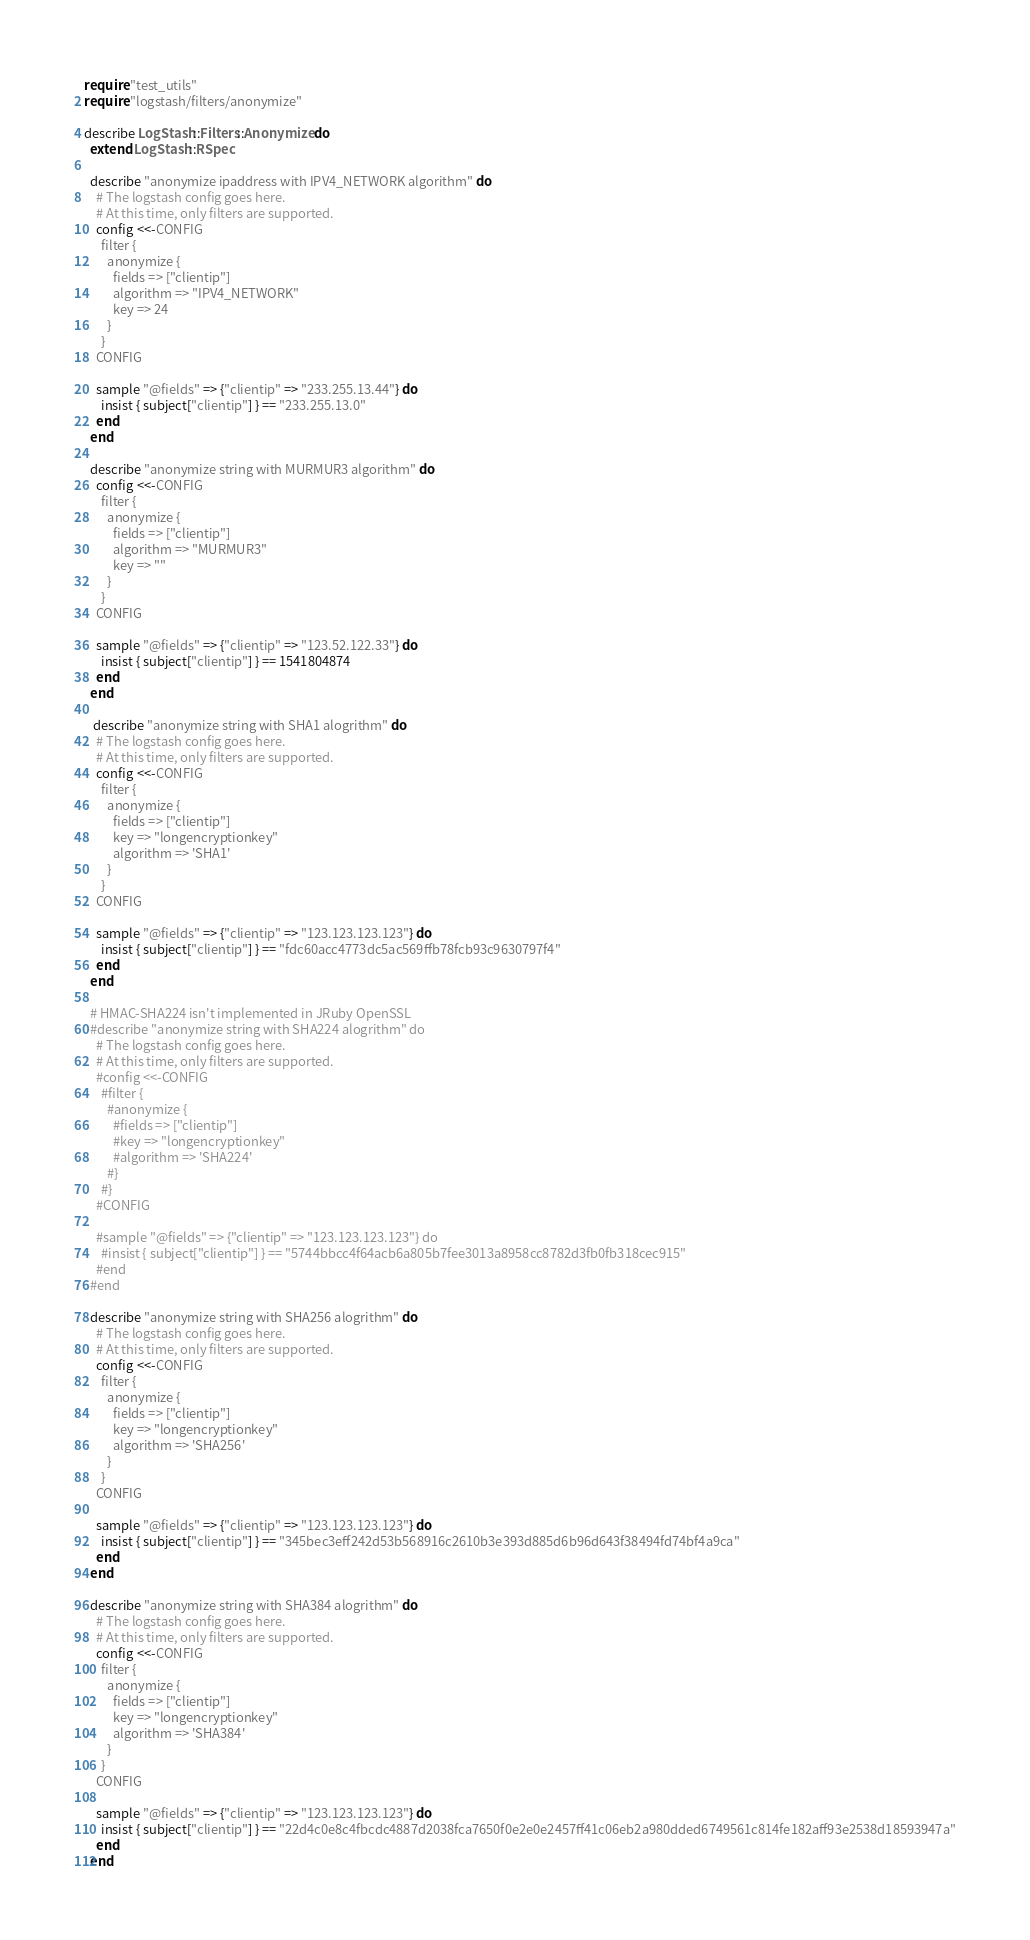<code> <loc_0><loc_0><loc_500><loc_500><_Ruby_>require "test_utils"
require "logstash/filters/anonymize"

describe LogStash::Filters::Anonymize do
  extend LogStash::RSpec

  describe "anonymize ipaddress with IPV4_NETWORK algorithm" do
    # The logstash config goes here.
    # At this time, only filters are supported.
    config <<-CONFIG
      filter {
        anonymize {
          fields => ["clientip"]
          algorithm => "IPV4_NETWORK"
          key => 24
        }
      }
    CONFIG

    sample "@fields" => {"clientip" => "233.255.13.44"} do
      insist { subject["clientip"] } == "233.255.13.0"
    end
  end

  describe "anonymize string with MURMUR3 algorithm" do
    config <<-CONFIG
      filter { 
        anonymize { 
          fields => ["clientip"]
          algorithm => "MURMUR3"
          key => ""
        }
      }
    CONFIG

    sample "@fields" => {"clientip" => "123.52.122.33"} do
      insist { subject["clientip"] } == 1541804874
    end
  end
 
   describe "anonymize string with SHA1 alogrithm" do
    # The logstash config goes here.
    # At this time, only filters are supported.
    config <<-CONFIG
      filter {
        anonymize {
          fields => ["clientip"]
          key => "longencryptionkey"
          algorithm => 'SHA1'
        }
      }
    CONFIG

    sample "@fields" => {"clientip" => "123.123.123.123"} do
      insist { subject["clientip"] } == "fdc60acc4773dc5ac569ffb78fcb93c9630797f4"
    end
  end

  # HMAC-SHA224 isn't implemented in JRuby OpenSSL
  #describe "anonymize string with SHA224 alogrithm" do
    # The logstash config goes here.
    # At this time, only filters are supported.
    #config <<-CONFIG
      #filter {
        #anonymize {
          #fields => ["clientip"]
          #key => "longencryptionkey"
          #algorithm => 'SHA224'
        #}
      #}
    #CONFIG

    #sample "@fields" => {"clientip" => "123.123.123.123"} do
      #insist { subject["clientip"] } == "5744bbcc4f64acb6a805b7fee3013a8958cc8782d3fb0fb318cec915"
    #end
  #end

  describe "anonymize string with SHA256 alogrithm" do
    # The logstash config goes here.
    # At this time, only filters are supported.
    config <<-CONFIG
      filter {
        anonymize {
          fields => ["clientip"]
          key => "longencryptionkey"
          algorithm => 'SHA256'
        }
      }
    CONFIG

    sample "@fields" => {"clientip" => "123.123.123.123"} do
      insist { subject["clientip"] } == "345bec3eff242d53b568916c2610b3e393d885d6b96d643f38494fd74bf4a9ca"
    end
  end

  describe "anonymize string with SHA384 alogrithm" do
    # The logstash config goes here.
    # At this time, only filters are supported.
    config <<-CONFIG
      filter {
        anonymize {
          fields => ["clientip"]
          key => "longencryptionkey"
          algorithm => 'SHA384'
        }
      }
    CONFIG

    sample "@fields" => {"clientip" => "123.123.123.123"} do
      insist { subject["clientip"] } == "22d4c0e8c4fbcdc4887d2038fca7650f0e2e0e2457ff41c06eb2a980dded6749561c814fe182aff93e2538d18593947a"
    end
  end
</code> 